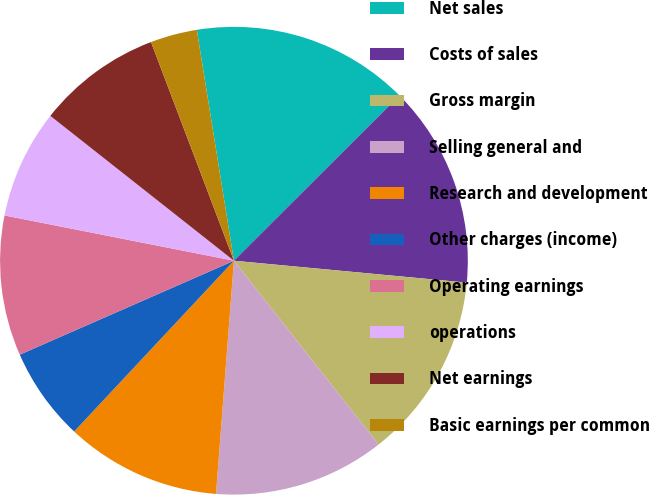<chart> <loc_0><loc_0><loc_500><loc_500><pie_chart><fcel>Net sales<fcel>Costs of sales<fcel>Gross margin<fcel>Selling general and<fcel>Research and development<fcel>Other charges (income)<fcel>Operating earnings<fcel>operations<fcel>Net earnings<fcel>Basic earnings per common<nl><fcel>15.05%<fcel>13.98%<fcel>12.9%<fcel>11.83%<fcel>10.75%<fcel>6.45%<fcel>9.68%<fcel>7.53%<fcel>8.6%<fcel>3.23%<nl></chart> 